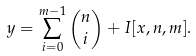<formula> <loc_0><loc_0><loc_500><loc_500>y = \sum _ { i = 0 } ^ { m - 1 } { n \choose i } + I [ x , n , m ] .</formula> 